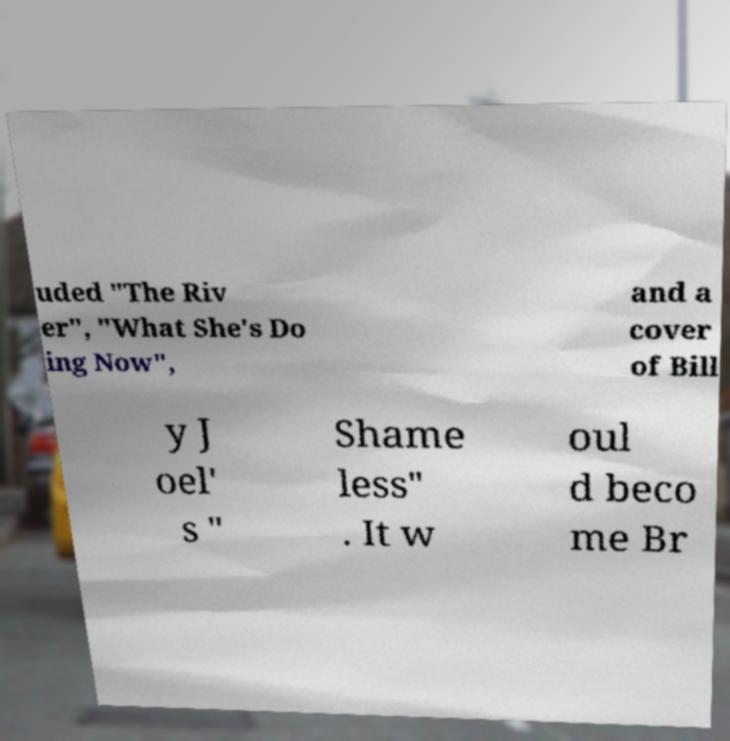Could you extract and type out the text from this image? uded "The Riv er", "What She's Do ing Now", and a cover of Bill y J oel' s " Shame less" . It w oul d beco me Br 